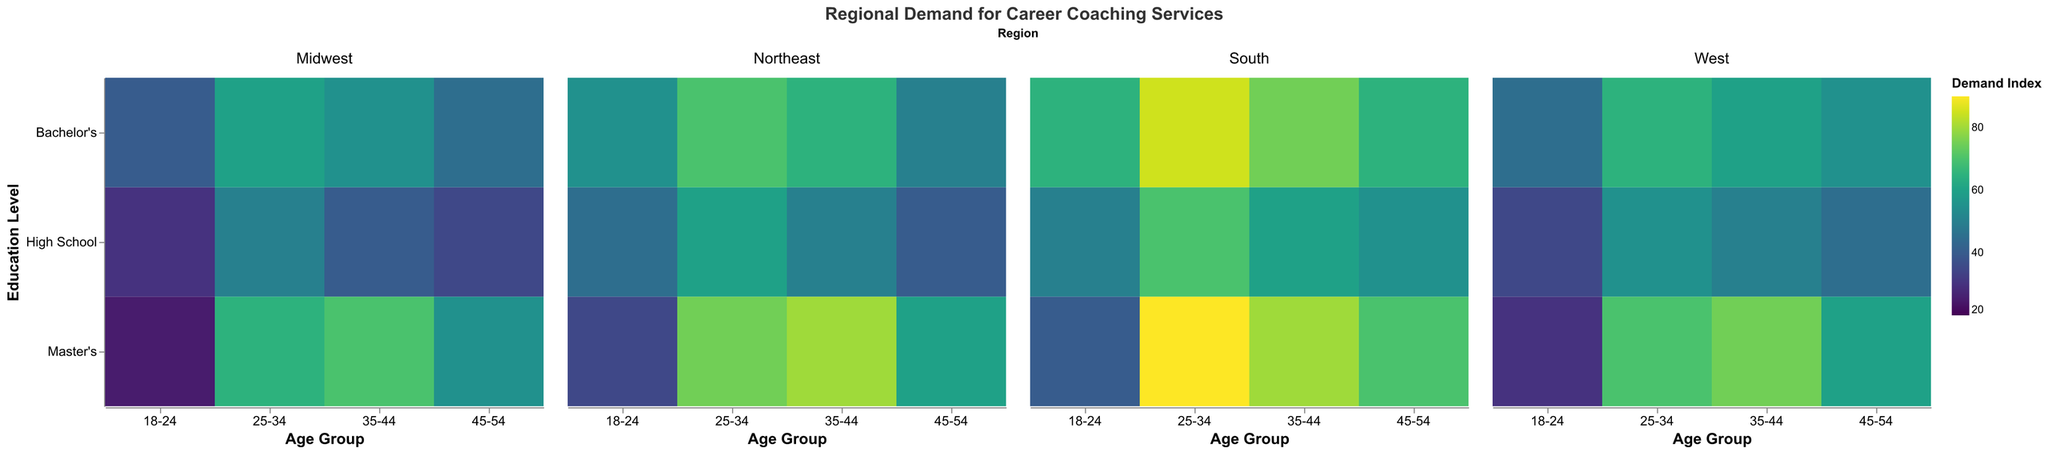What is the title of the heatmap? The title is usually located at the top of the heatmap and provides an overview of what the visualization represents.
Answer: Regional Demand for Career Coaching Services How does the demand for career coaching services for 25-34-year-olds with a Master's degree in the Northeast compare to the Midwest? Compare the color intensity of the rectangles corresponding to "25-34" age group and "Master's" education level in both the "Northeast" and "Midwest" regions. Higher intensity indicates higher demand.
Answer: Northeast has higher demand Which age group and education level in the South has the highest demand for career coaching services? Look at the color intensity for the "South" region and identify the rectangle with the highest intensity.
Answer: 25-34, Master's What is the median demand index for the Northeast region? Collect all the demand indices for the Northeast region, sort them, and find the middle value. If the number of values is even, the median is the average of the two middle numbers. Indices: [35, 40, 45, 50, 50, 55, 60, 60, 65, 70, 75, 80].
Answer: 57.5 Which region has the overall lowest demand for the age group 45-54 with a Bachelor's degree? Compare the color intensity of the rectangles corresponding to "45-54" age group and "Bachelor's" education level across all regions.
Answer: Midwest What is the demand index difference between 18-24 and 35-44 age groups with a Bachelor's degree in the West region? Subtract the demand index of the "18-24" age group with a Bachelor's degree from the "35-44" age group with a Bachelor's degree in the West region.
Answer: 15 (60 - 45) Is there a correlation between higher education levels and higher demand for career coaching services in the Northeast region for all age groups? Compare the color intensity sequentially from "High School" to "Master's" within each age group in the Northeast region to see if there is a consistent trend.
Answer: Yes For the Midwest region, what is the average demand index for the 25-34 age group across all education levels? Sum the demand indices for "25-34" age group across all education levels and divide by the number of data points. (50 + 60 + 65) / 3
Answer: 58.33 